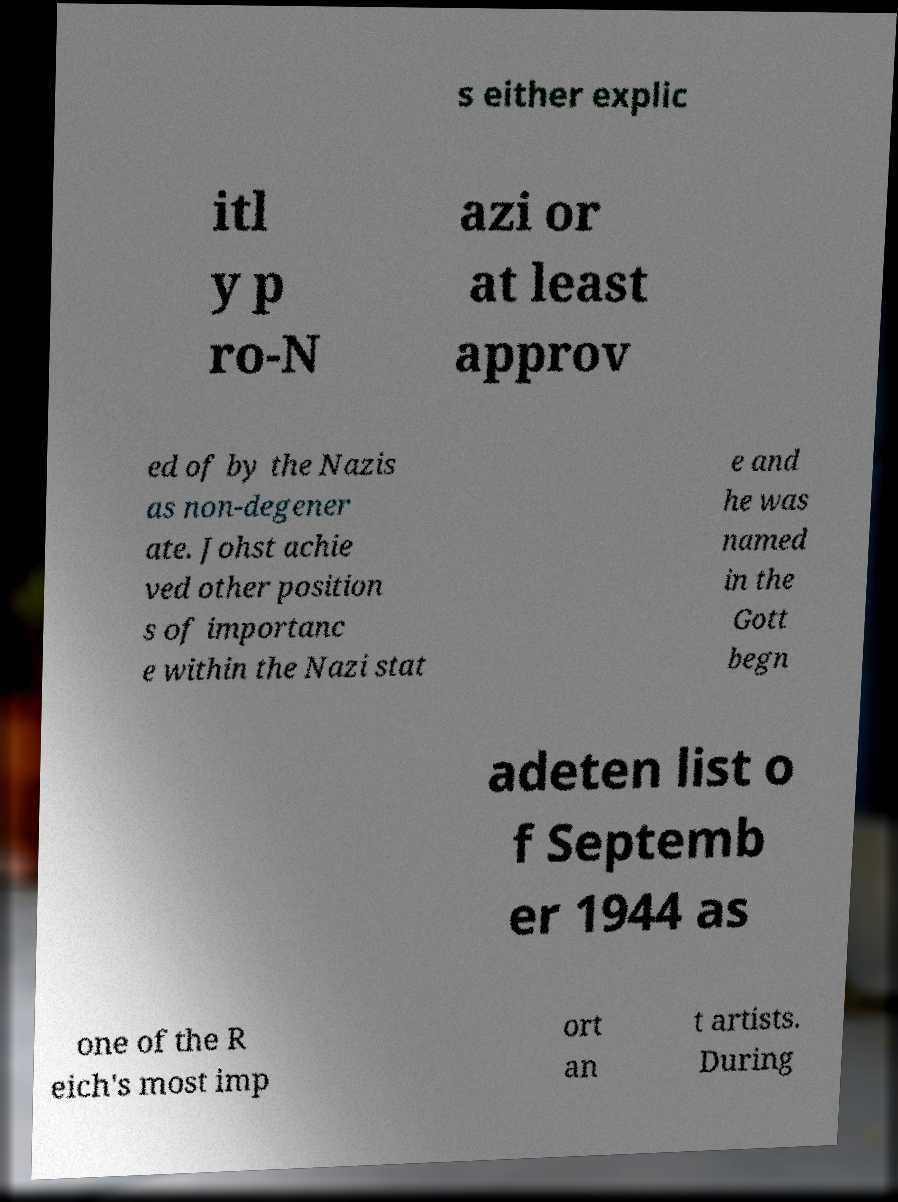What messages or text are displayed in this image? I need them in a readable, typed format. s either explic itl y p ro-N azi or at least approv ed of by the Nazis as non-degener ate. Johst achie ved other position s of importanc e within the Nazi stat e and he was named in the Gott begn adeten list o f Septemb er 1944 as one of the R eich's most imp ort an t artists. During 